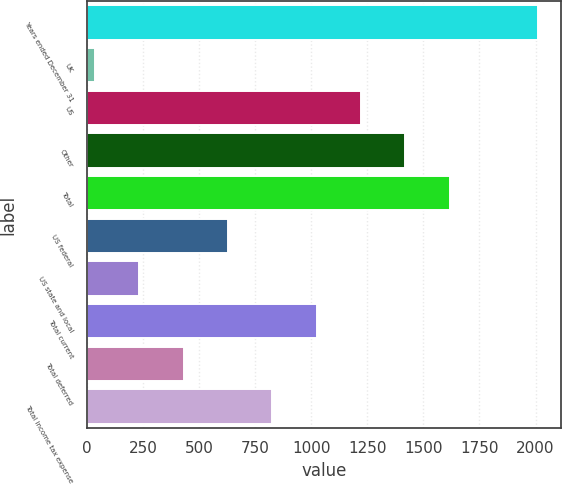<chart> <loc_0><loc_0><loc_500><loc_500><bar_chart><fcel>Years ended December 31<fcel>UK<fcel>US<fcel>Other<fcel>Total<fcel>US federal<fcel>US state and local<fcel>Total current<fcel>Total deferred<fcel>Total income tax expense<nl><fcel>2012<fcel>36<fcel>1221.6<fcel>1419.2<fcel>1616.8<fcel>628.8<fcel>233.6<fcel>1024<fcel>431.2<fcel>826.4<nl></chart> 